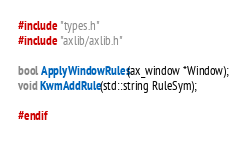<code> <loc_0><loc_0><loc_500><loc_500><_C_>
#include "types.h"
#include "axlib/axlib.h"

bool ApplyWindowRules(ax_window *Window);
void KwmAddRule(std::string RuleSym);

#endif
</code> 